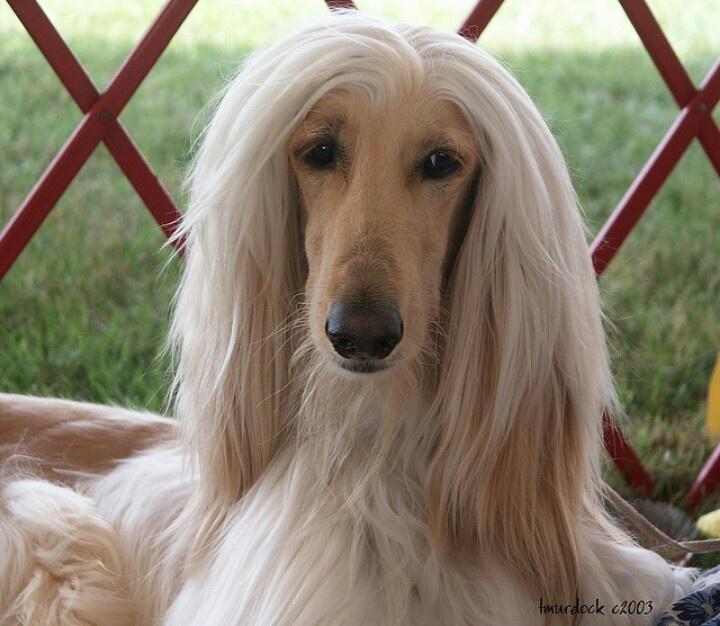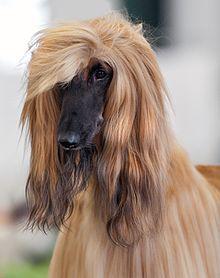The first image is the image on the left, the second image is the image on the right. Analyze the images presented: Is the assertion "There is an Afghan dog being held on a leash." valid? Answer yes or no. No. The first image is the image on the left, the second image is the image on the right. Given the left and right images, does the statement "One image shows a light-colored afghan hound gazing rightward into the distance." hold true? Answer yes or no. No. 